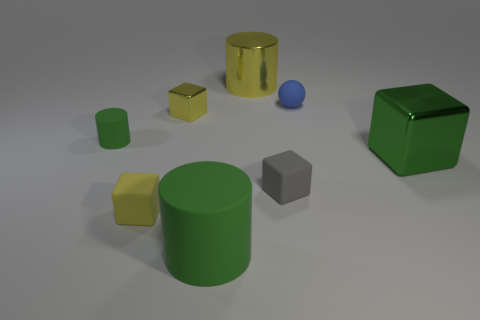Add 2 small yellow cubes. How many objects exist? 10 Subtract all cylinders. How many objects are left? 5 Subtract 1 green cubes. How many objects are left? 7 Subtract all gray matte objects. Subtract all large metallic objects. How many objects are left? 5 Add 1 large matte cylinders. How many large matte cylinders are left? 2 Add 7 brown metal cylinders. How many brown metal cylinders exist? 7 